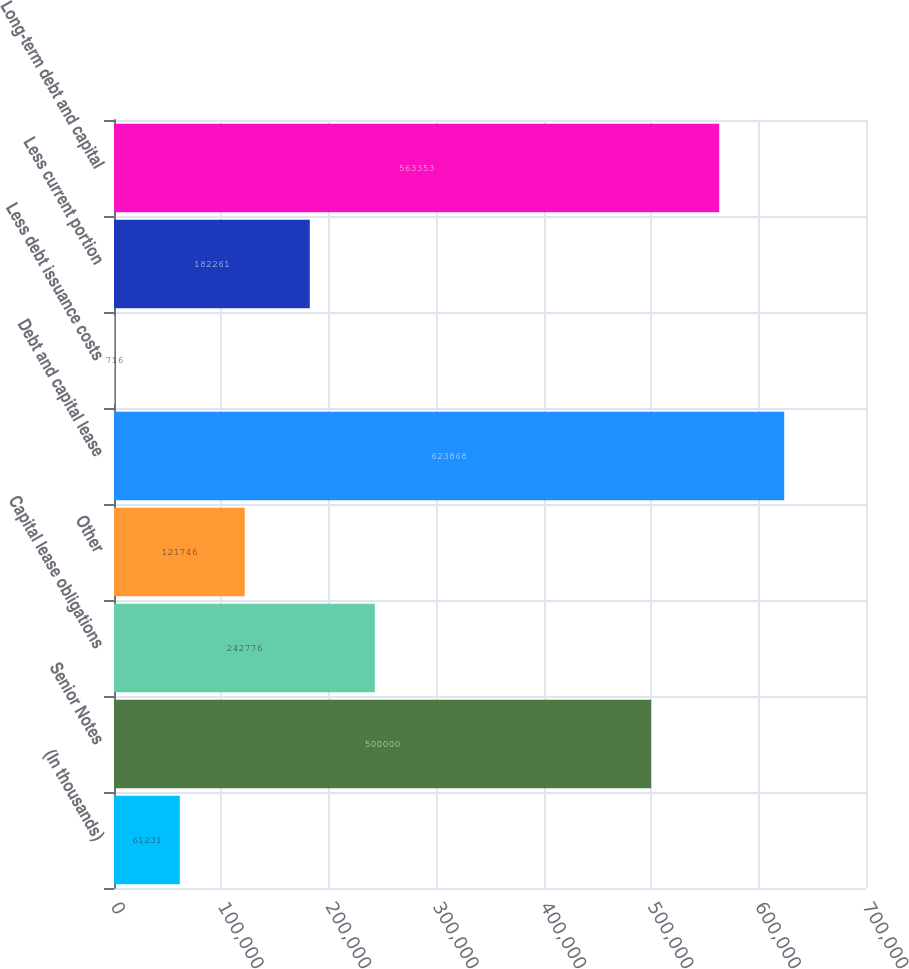Convert chart to OTSL. <chart><loc_0><loc_0><loc_500><loc_500><bar_chart><fcel>(In thousands)<fcel>Senior Notes<fcel>Capital lease obligations<fcel>Other<fcel>Debt and capital lease<fcel>Less debt issuance costs<fcel>Less current portion<fcel>Long-term debt and capital<nl><fcel>61231<fcel>500000<fcel>242776<fcel>121746<fcel>623868<fcel>716<fcel>182261<fcel>563353<nl></chart> 